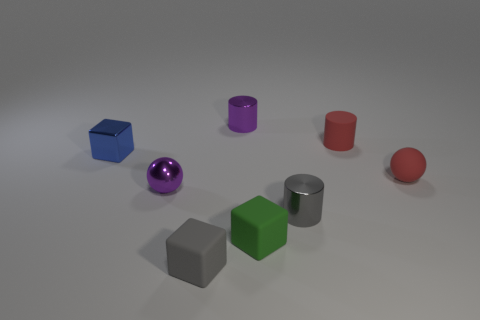Add 1 tiny purple shiny cylinders. How many objects exist? 9 Subtract all spheres. How many objects are left? 6 Subtract all green cubes. Subtract all tiny red objects. How many objects are left? 5 Add 7 tiny purple objects. How many tiny purple objects are left? 9 Add 4 balls. How many balls exist? 6 Subtract 1 purple cylinders. How many objects are left? 7 